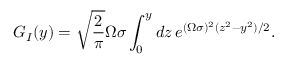<formula> <loc_0><loc_0><loc_500><loc_500>G _ { I } ( y ) = \sqrt { \frac { 2 } { \pi } } \Omega \sigma \int _ { 0 } ^ { y } d z \, e ^ { ( \Omega \sigma ) ^ { 2 } ( z ^ { 2 } - y ^ { 2 } ) / 2 } .</formula> 